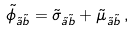<formula> <loc_0><loc_0><loc_500><loc_500>\tilde { \phi } _ { \tilde { a } \tilde { b } } = \tilde { \sigma } _ { \tilde { a } \tilde { b } } + \tilde { \mu } _ { \tilde { a } \tilde { b } } \, ,</formula> 